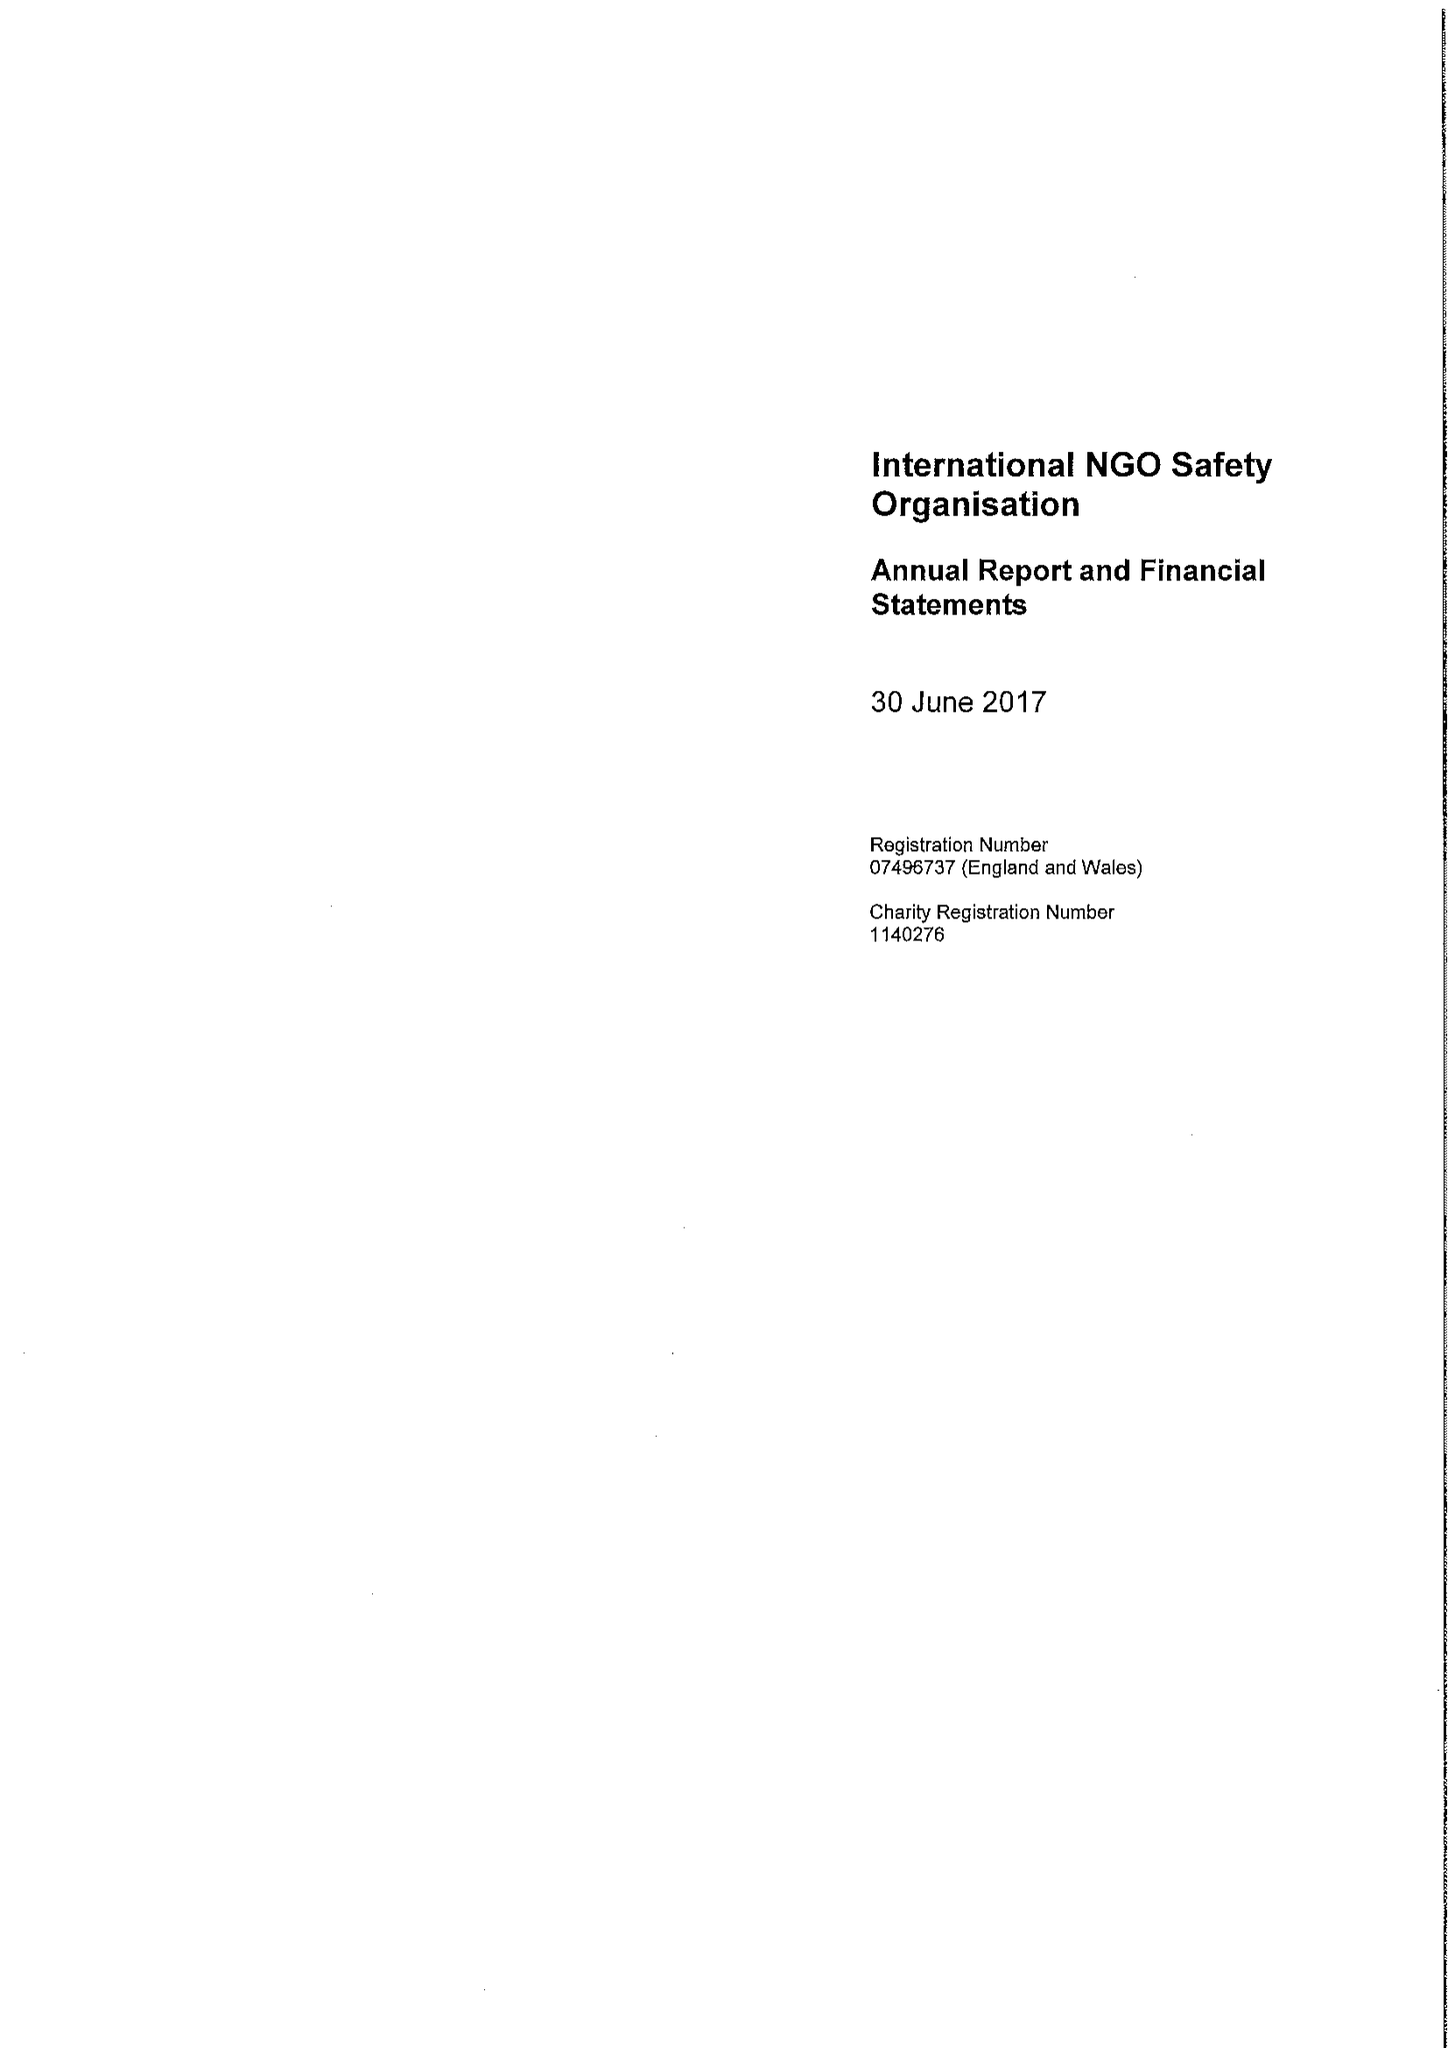What is the value for the address__post_town?
Answer the question using a single word or phrase. LONDON 